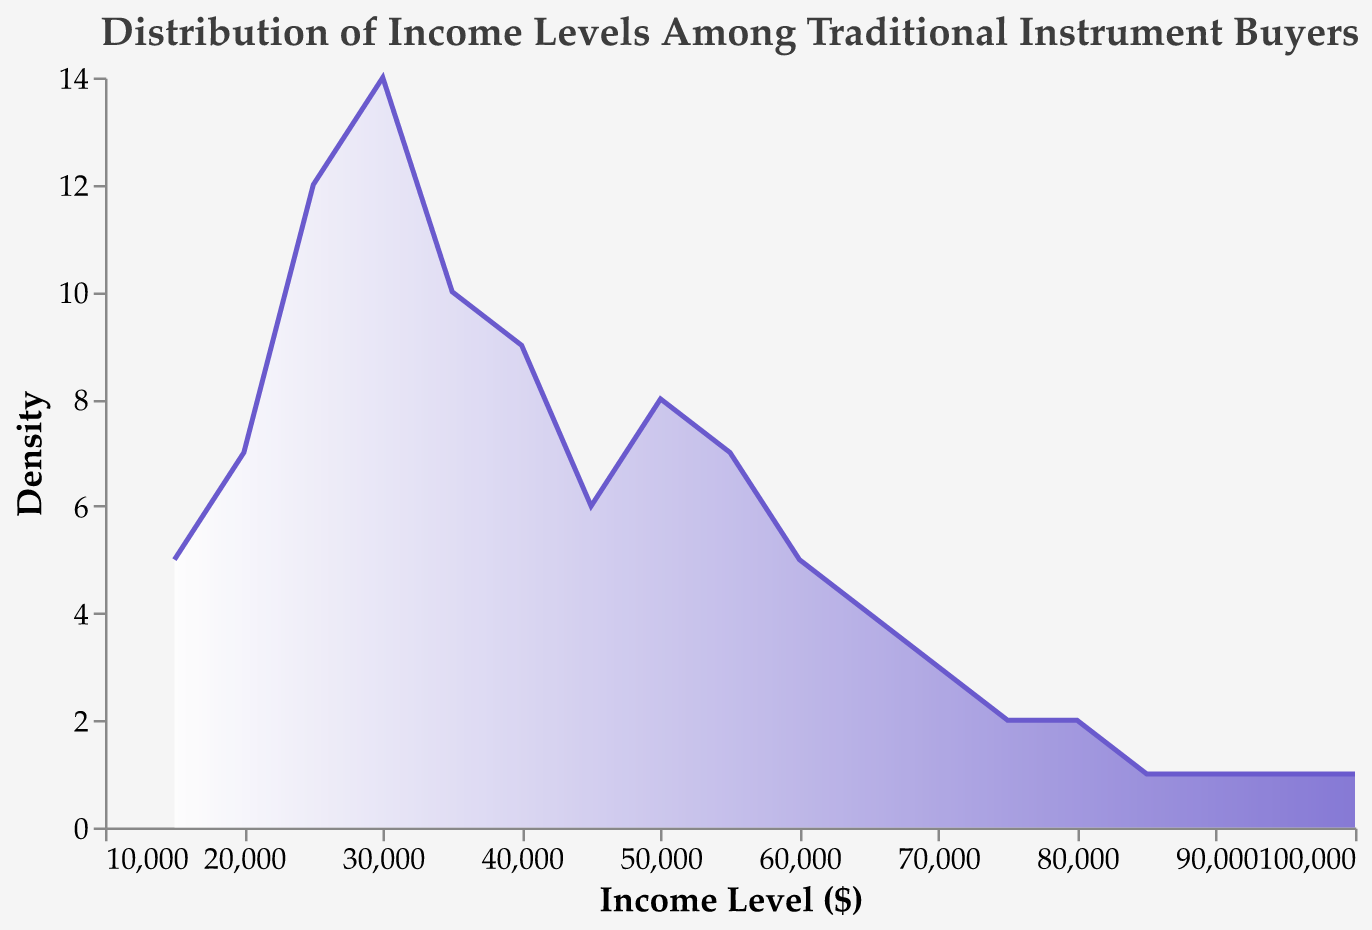What is the title of the plot? The title is usually at the top of the plot and describes what the data is about. Here, the title reads "Distribution of Income Levels Among Traditional Instrument Buyers."
Answer: Distribution of Income Levels Among Traditional Instrument Buyers What is the income level with the highest number of purchases? To find this, look at the peak of the density curve on the plot. The highest point represents the income level with the most purchases. In this case, the peak appears around $30,000.
Answer: $30,000 How many data points are used in the plot? Each distinct value of the Income_Level is a data point. By counting them, we see there are 18 income levels listed.
Answer: 18 Which income levels have the least number of purchases? The least number of purchases is indicated by the lowest values on the y-axis. Observing the plot, the income levels $85,000, $90,000, $95,000, and $100,000 all have the lowest number of purchases, which is 1.
Answer: $85,000, $90,000, $95,000, and $100,000 What is the general shape of the distribution of income levels? The shape of the density plot shows how the values are spread out. This plot has a peak around $30,000 and gradually tapers off towards higher income levels, resulting in a right-skewed distribution.
Answer: Right-skewed What are the approximate median and mode income levels? The mode is the highest peak on the density plot, and the median is the middle value when the data is ordered. The mode is around $30,000 (highest peak), and the median is near $37,500 as the values seem equally distributed around it.
Answer: Mode: $30,000, Median: $37,500 Is there a substantial density change between $20,000 and $40,000 income levels? Observe the steepness and height variation of the plot between these income levels. The density increases significantly from $20,000 to around $30,000 and then starts to decrease towards $40,000.
Answer: Yes Do income levels above $70,000 have higher, lower, or equal purchases compared to those below $30,000? By comparing the height of the plot's density curves, purchases are generally lower for income levels above $70,000 than those below $30,000.
Answer: Lower How does the gradient color change in the plot? The color gradient starts from white at the bottom and gradually changes to purple towards the top. This helps visually emphasize the density levels.
Answer: From white to purple What can we infer about the target audience's income levels for traditional instruments? The plot suggests that most purchases come from individuals with income levels around $30,000 to $40,000, indicating this range might be the target audience for traditional instruments. The density tapers off for both lower and higher income levels.
Answer: Most purchases from $30,000 to $40,000 ranges 